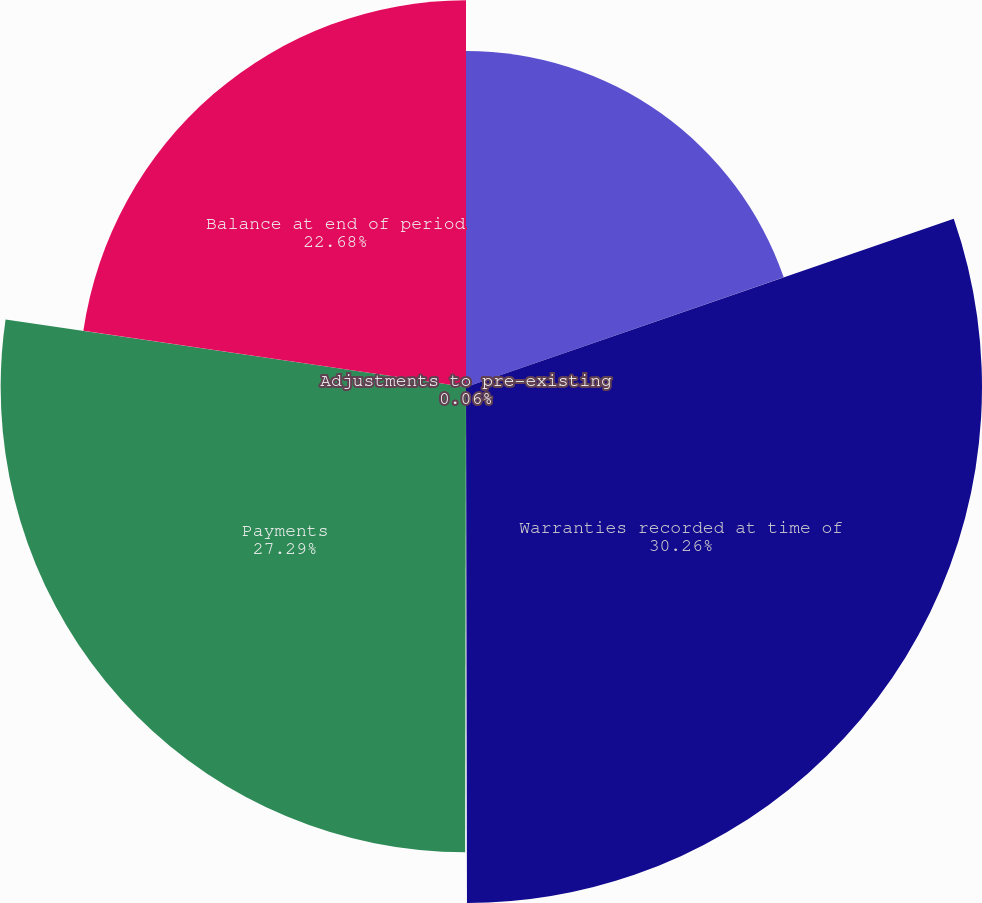Convert chart. <chart><loc_0><loc_0><loc_500><loc_500><pie_chart><fcel>Balance at beginning of period<fcel>Warranties recorded at time of<fcel>Adjustments to pre-existing<fcel>Payments<fcel>Balance at end of period<nl><fcel>19.71%<fcel>30.26%<fcel>0.06%<fcel>27.29%<fcel>22.68%<nl></chart> 